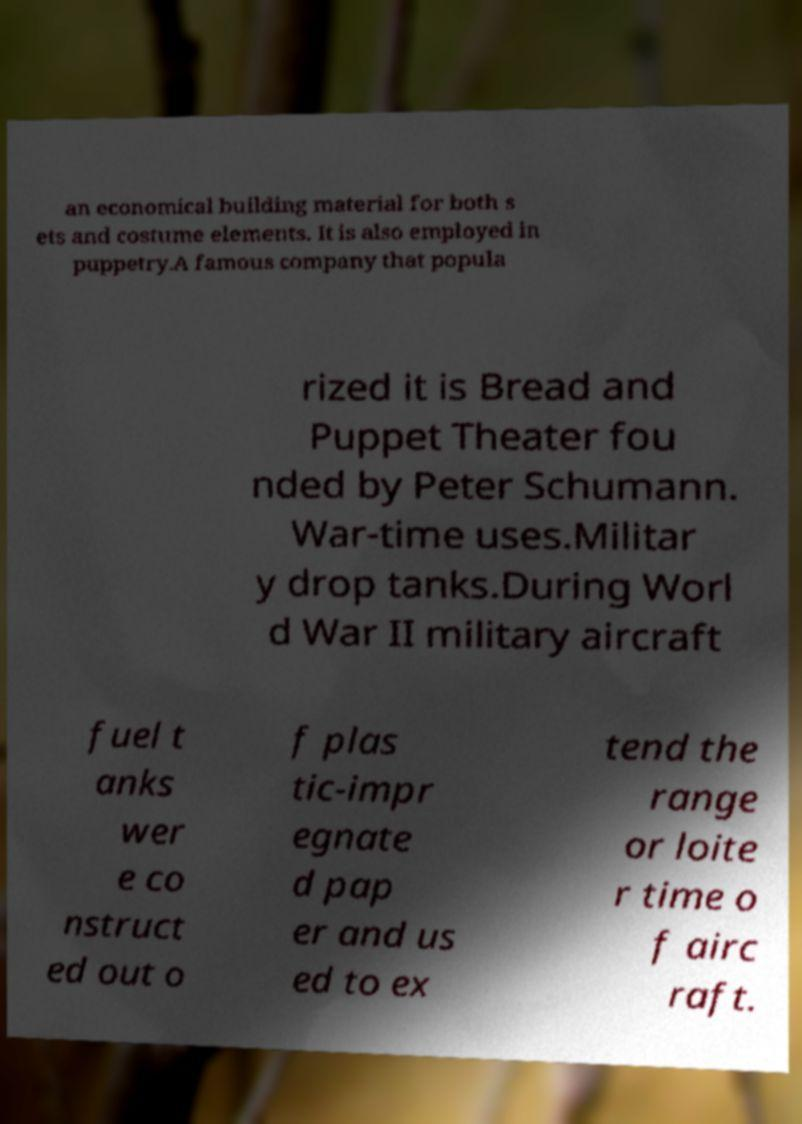For documentation purposes, I need the text within this image transcribed. Could you provide that? an economical building material for both s ets and costume elements. It is also employed in puppetry.A famous company that popula rized it is Bread and Puppet Theater fou nded by Peter Schumann. War-time uses.Militar y drop tanks.During Worl d War II military aircraft fuel t anks wer e co nstruct ed out o f plas tic-impr egnate d pap er and us ed to ex tend the range or loite r time o f airc raft. 